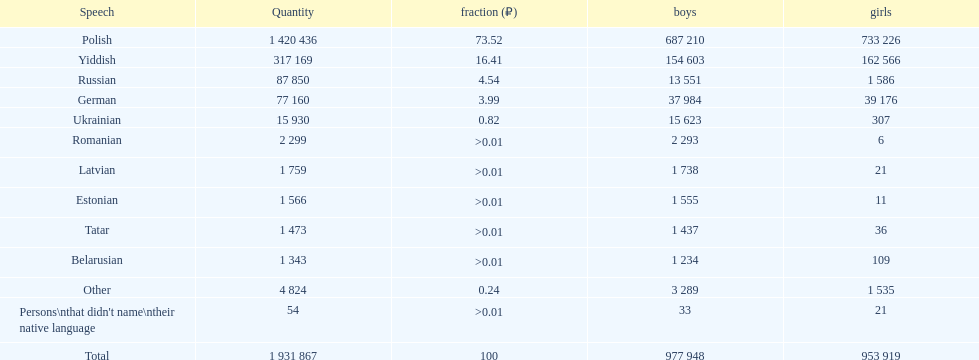What is the highest percentage of speakers other than polish? Yiddish. 